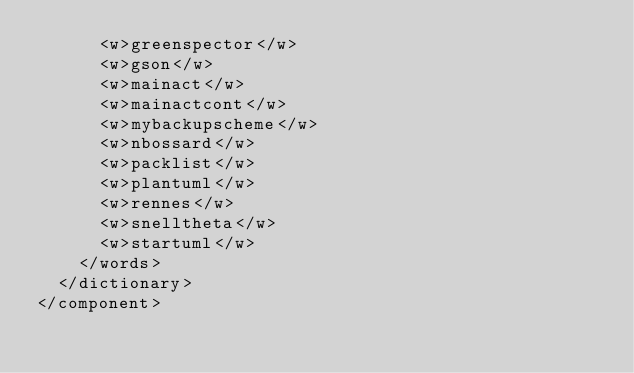Convert code to text. <code><loc_0><loc_0><loc_500><loc_500><_XML_>      <w>greenspector</w>
      <w>gson</w>
      <w>mainact</w>
      <w>mainactcont</w>
      <w>mybackupscheme</w>
      <w>nbossard</w>
      <w>packlist</w>
      <w>plantuml</w>
      <w>rennes</w>
      <w>snelltheta</w>
      <w>startuml</w>
    </words>
  </dictionary>
</component></code> 